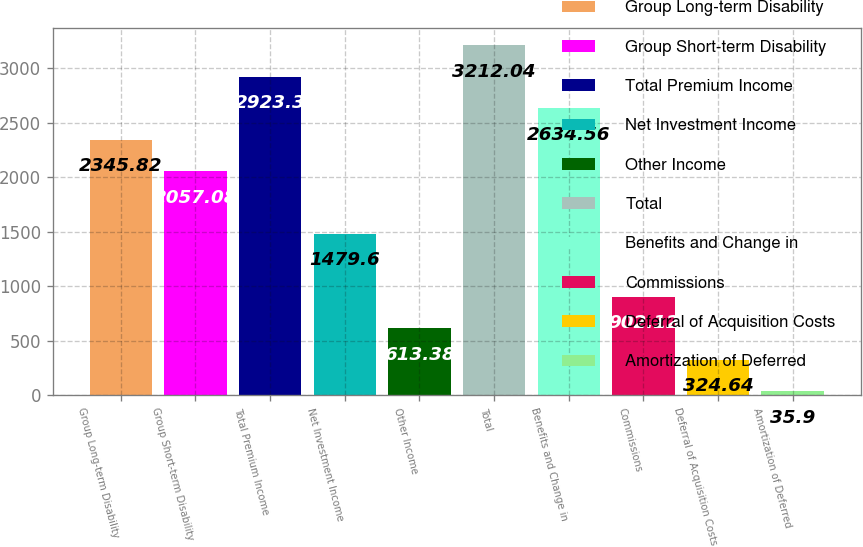Convert chart to OTSL. <chart><loc_0><loc_0><loc_500><loc_500><bar_chart><fcel>Group Long-term Disability<fcel>Group Short-term Disability<fcel>Total Premium Income<fcel>Net Investment Income<fcel>Other Income<fcel>Total<fcel>Benefits and Change in<fcel>Commissions<fcel>Deferral of Acquisition Costs<fcel>Amortization of Deferred<nl><fcel>2345.82<fcel>2057.08<fcel>2923.3<fcel>1479.6<fcel>613.38<fcel>3212.04<fcel>2634.56<fcel>902.12<fcel>324.64<fcel>35.9<nl></chart> 